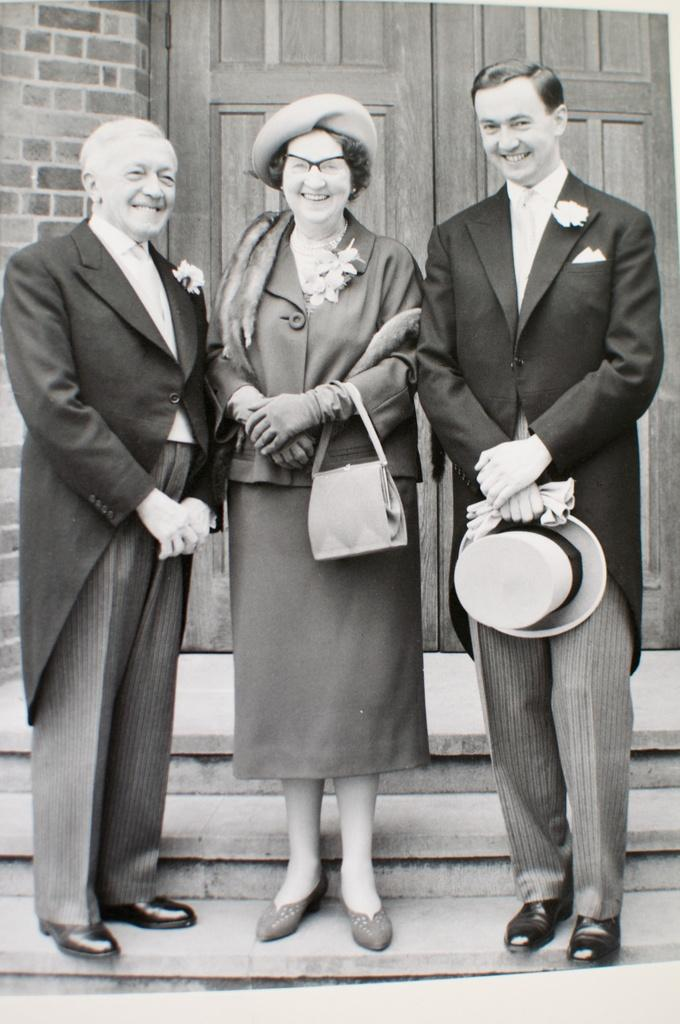How many people are in the image? There are three people in the image: two men and one woman. What are the people in the image doing? The two men and the woman are standing and laughing. What type of mint is being used to decorate the cakes in the image? There are no cakes or mint present in the image; it features two men and a woman standing and laughing. 